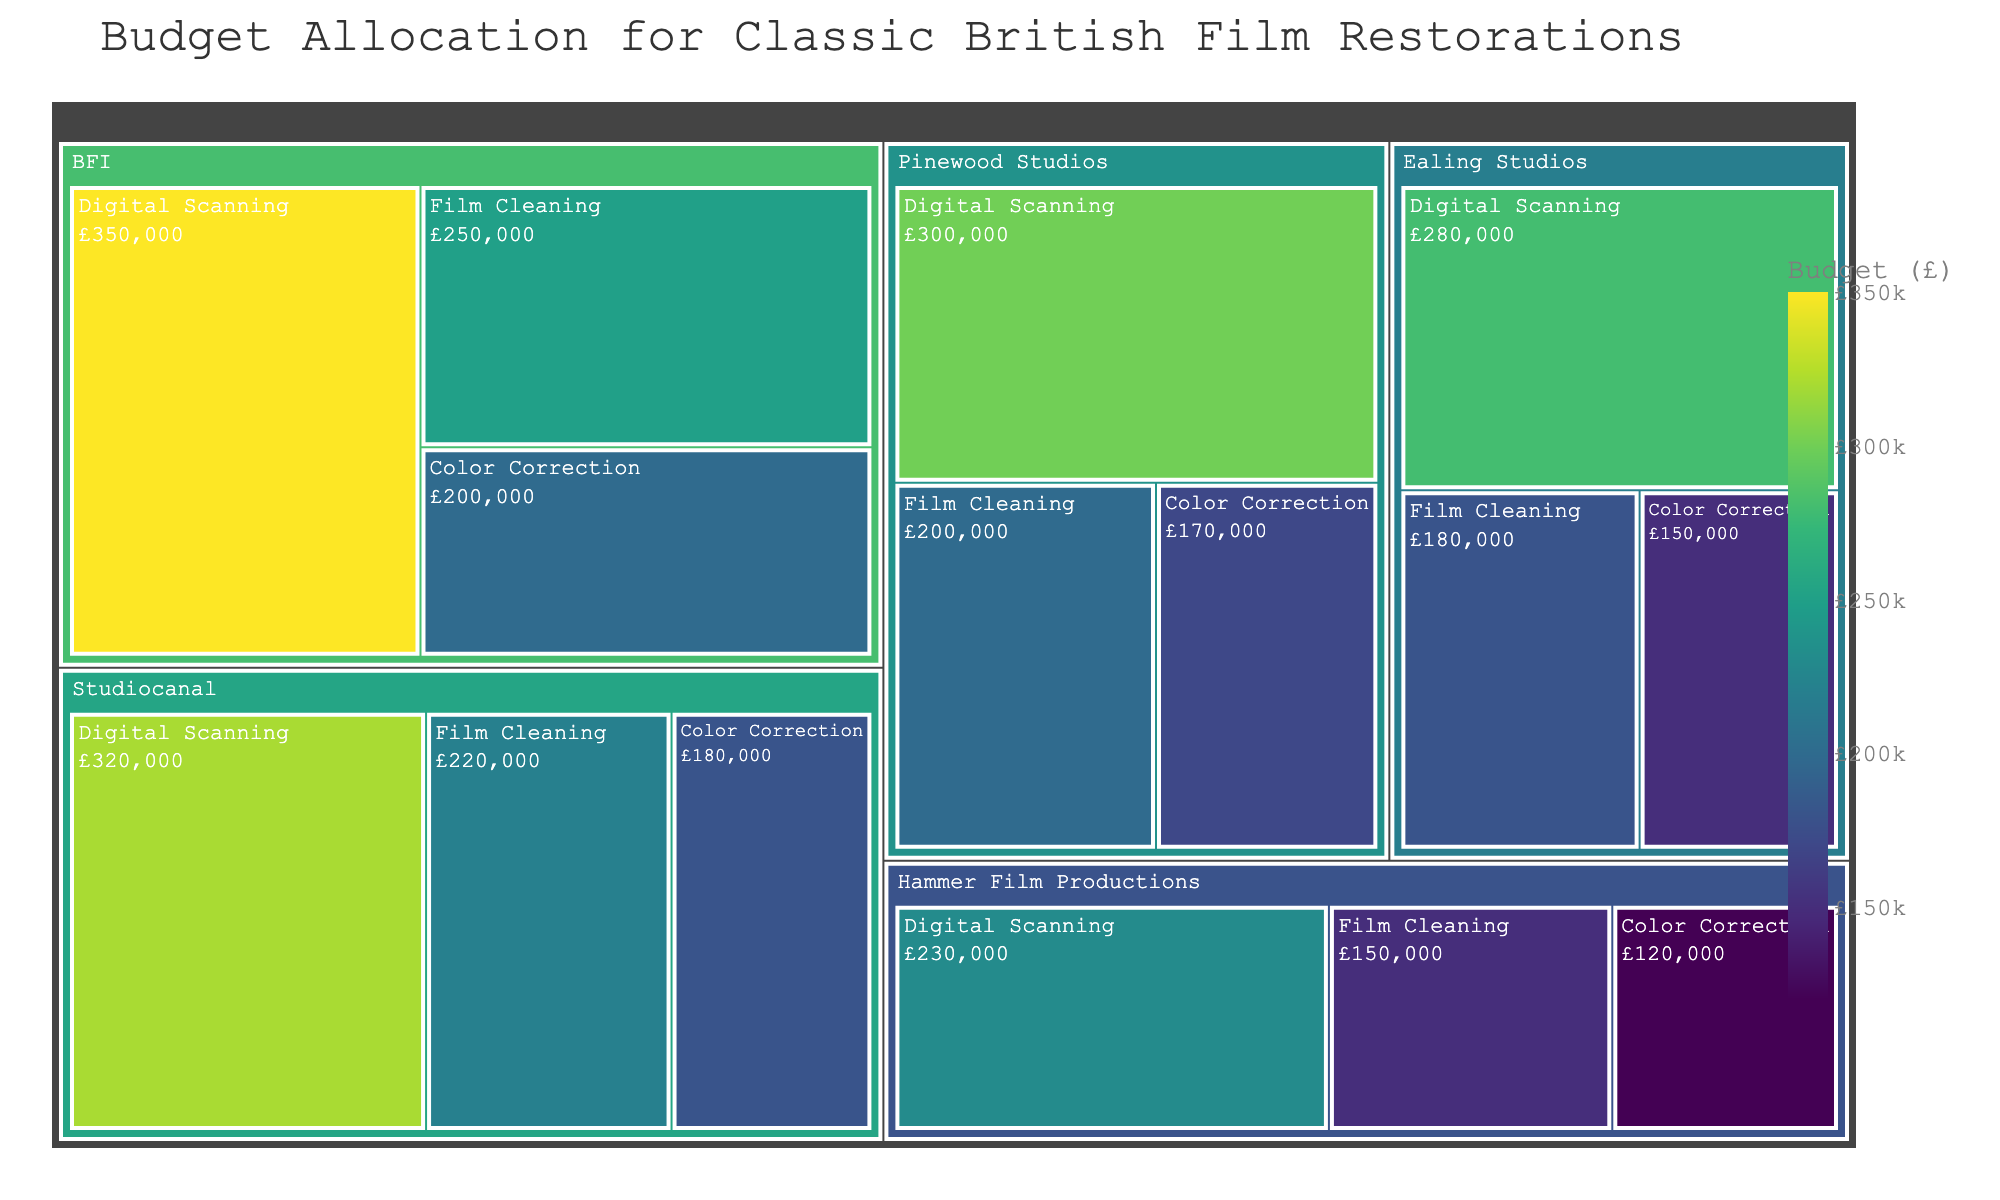What is the total budget allocation for all studios combined? Sum up the budget from all studios. Total budget = 250000 + 350000 + 200000 + 180000 + 280000 + 150000 + 220000 + 320000 + 180000 + 200000 + 300000 + 170000 + 150000 + 230000 + 120000 = 3,380,000
Answer: 3,380,000 Which studio has the highest budget allocation for digital scanning? Compare the budgets for digital scanning across all studios: BFI (£350,000), Ealing Studios (£280,000), Studiocanal (£320,000), Pinewood Studios (£300,000), Hammer Film Productions (£230,000). BFI has the highest budget.
Answer: BFI How does the budget for film cleaning at Pinewood Studios compare to that at Studiocanal? Film cleaning budget for Pinewood Studios (£200,000) vs Studiocanal (£220,000). Studiocanal has a higher budget.
Answer: Studiocanal What is the average budget allocation for color correction across all studios? Sum the budgets for color correction (200000 + 150000 + 180000 + 170000 + 120000) = 820000. Calculate the average: 820000 / 5 = 164000
Answer: 164000 Which restoration process has the largest overall budget across all studios? Sum budgets for each restoration process: Film cleaning (250000 + 180000 + 220000 + 200000 + 150000) = 1,000,000, Digital scanning (350000 + 280000 + 320000 + 300000 + 230000) = 1,480,000, Color correction (200000 + 150000 + 180000 + 170000 + 120000) = 820,000. Digital scanning has the largest budget.
Answer: Digital scanning Which studio has the smallest total budget allocation among all its restoration processes? Sum the budgets for each studio: BFI (250000 + 350000 + 200000 = 800000), Ealing Studios (180000 + 280000 + 150000 = 610000), Studiocanal (220000 + 320000 + 180000 = 720000), Pinewood Studios (200000 + 300000 + 170000 = 670000), Hammer Film Productions (150000 + 230000 + 120000 = 500000). Hammer Film Productions has the smallest total budget.
Answer: Hammer Film Productions What is the budget difference between the largest and smallest budget allocations for film cleaning across all studios? Largest budget for film cleaning = 250,000 (BFI), smallest = 150,000 (Hammer Film Productions). Difference = 250,000 - 150,000 = 100,000
Answer: 100,000 How much more is spent on digital scanning compared to film cleaning at BFI? BFI's budget for digital scanning (£350,000) and film cleaning (£250,000). Difference = 350,000 - 250,000 = 100,000
Answer: 100,000 